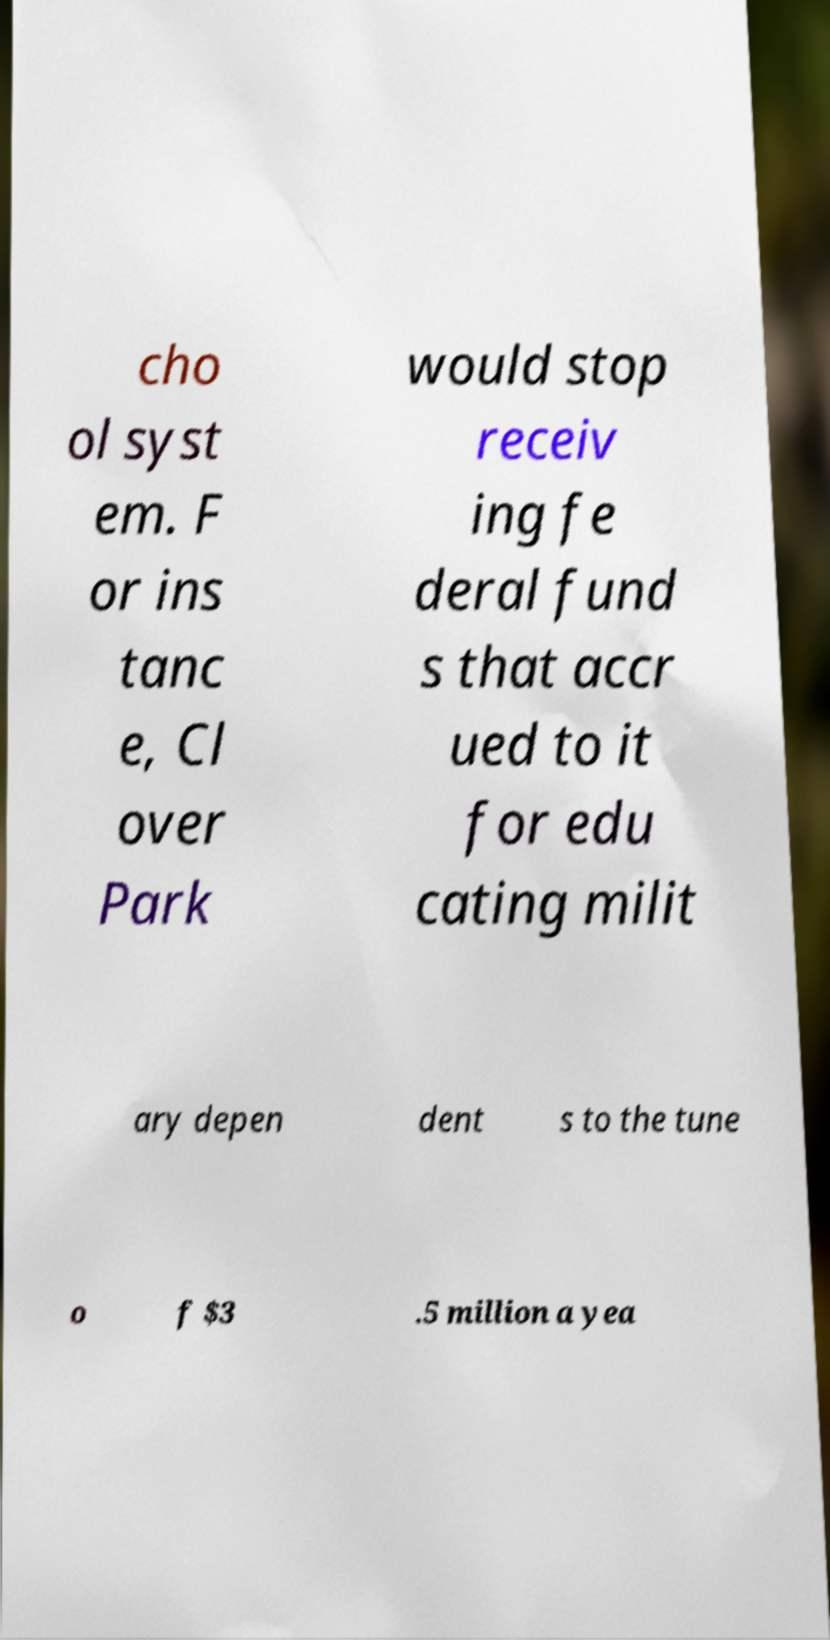Can you read and provide the text displayed in the image?This photo seems to have some interesting text. Can you extract and type it out for me? cho ol syst em. F or ins tanc e, Cl over Park would stop receiv ing fe deral fund s that accr ued to it for edu cating milit ary depen dent s to the tune o f $3 .5 million a yea 